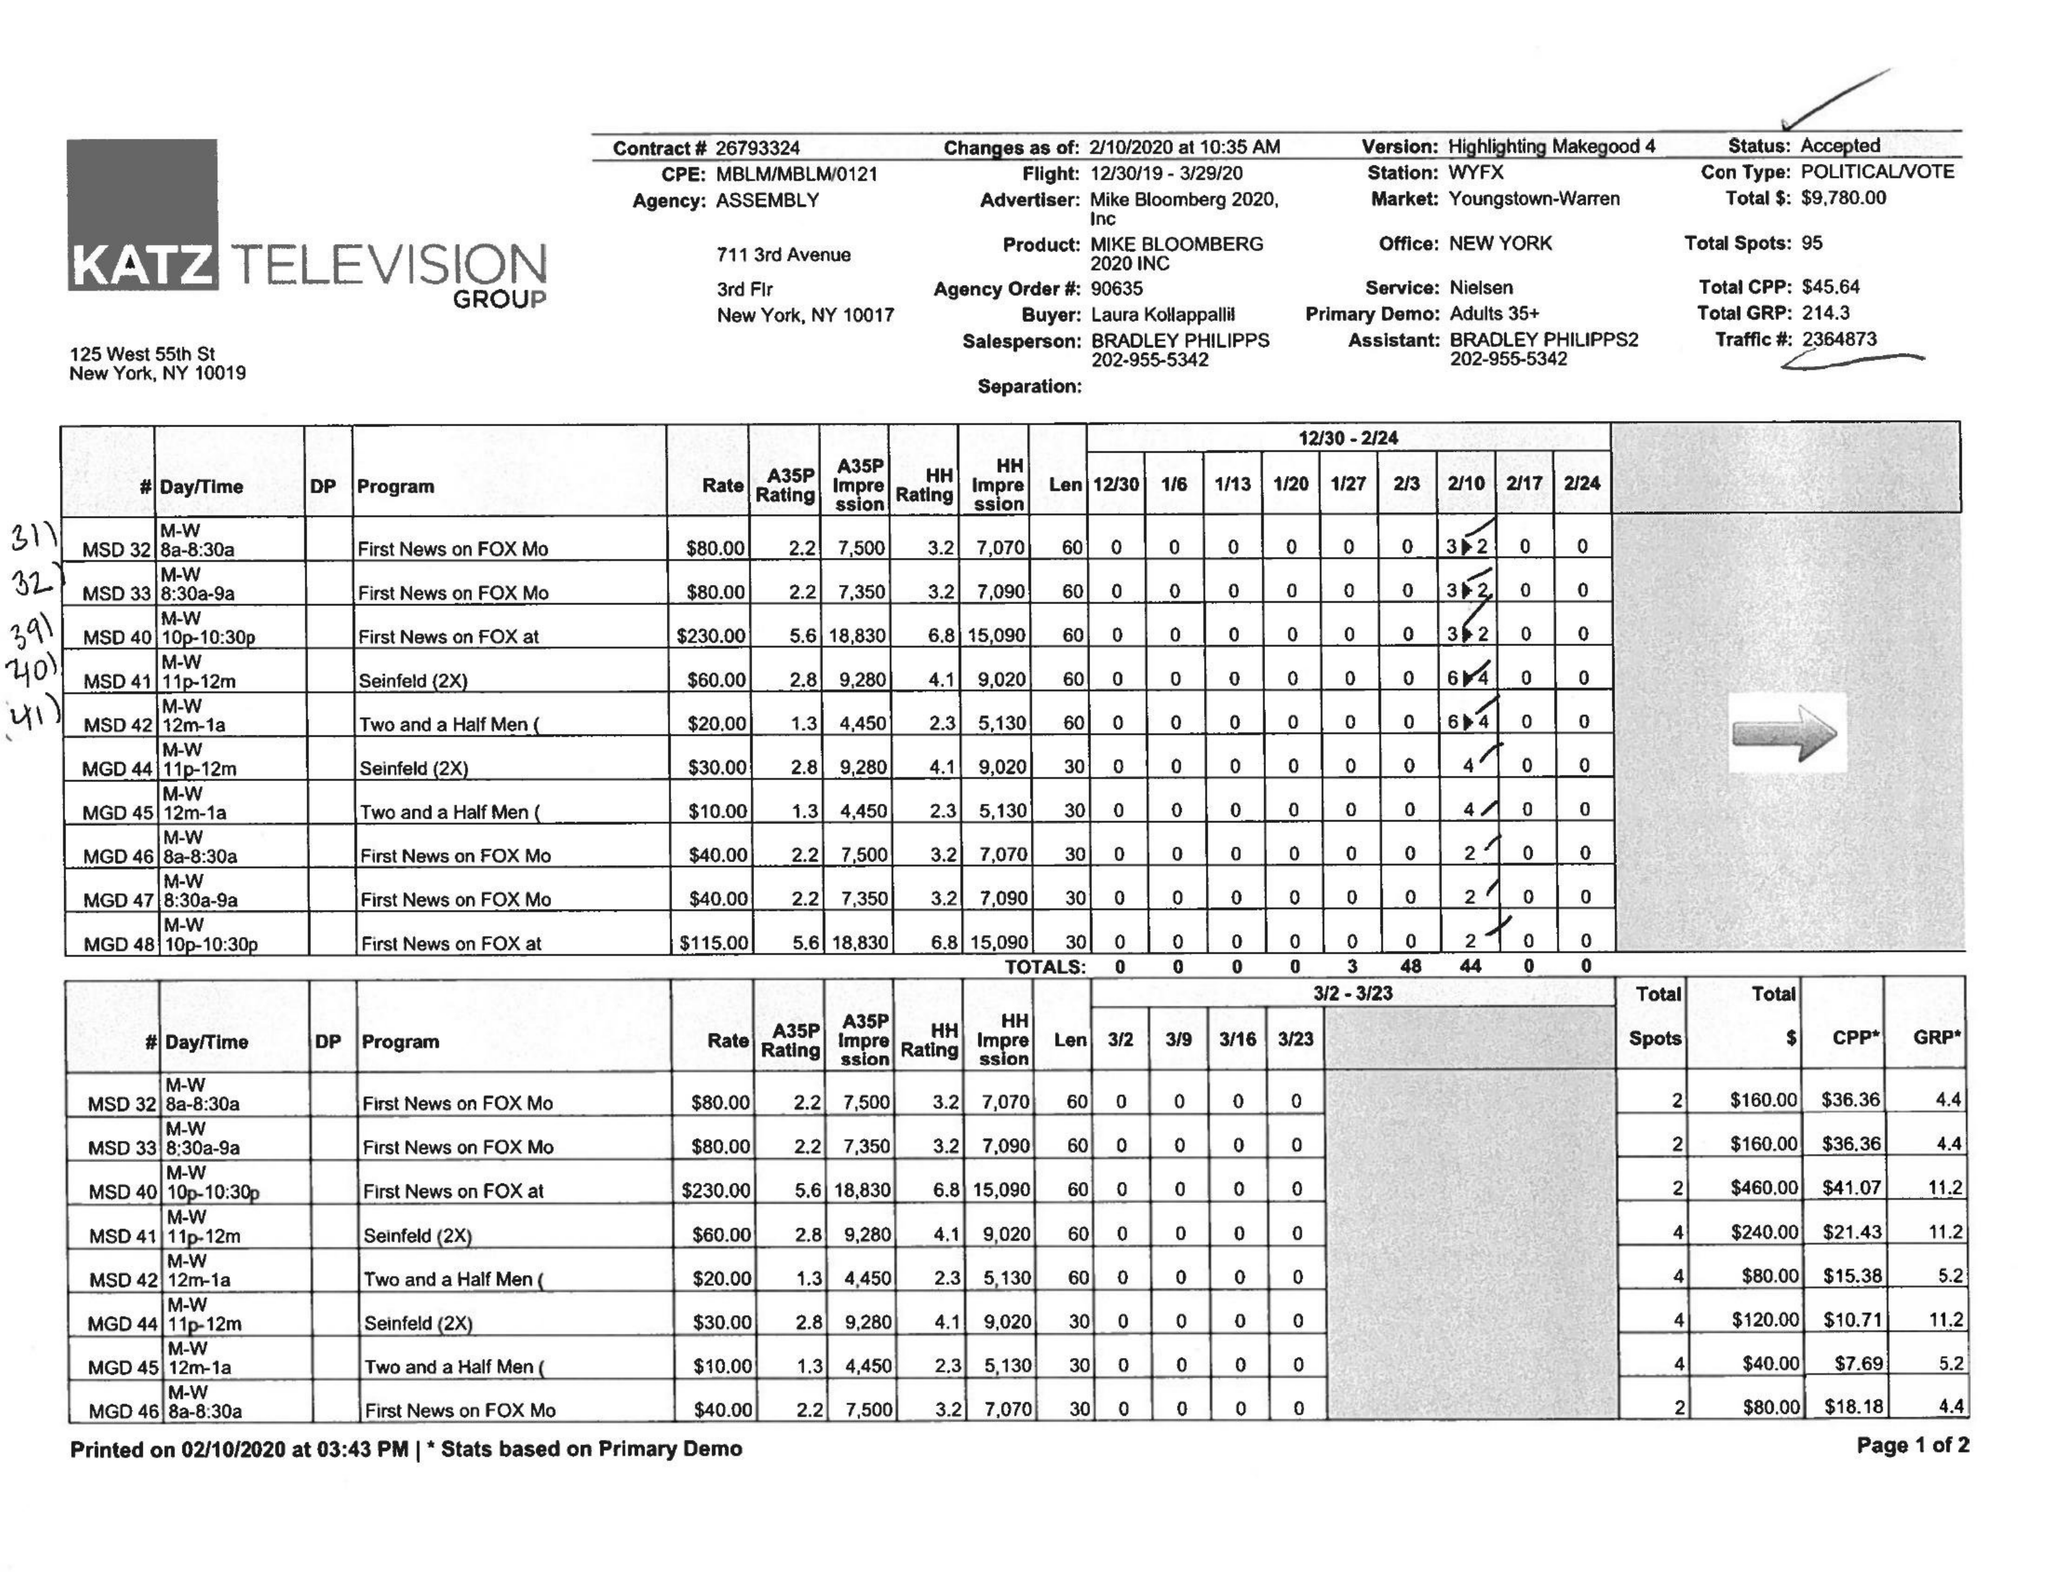What is the value for the flight_to?
Answer the question using a single word or phrase. 03/29/20 